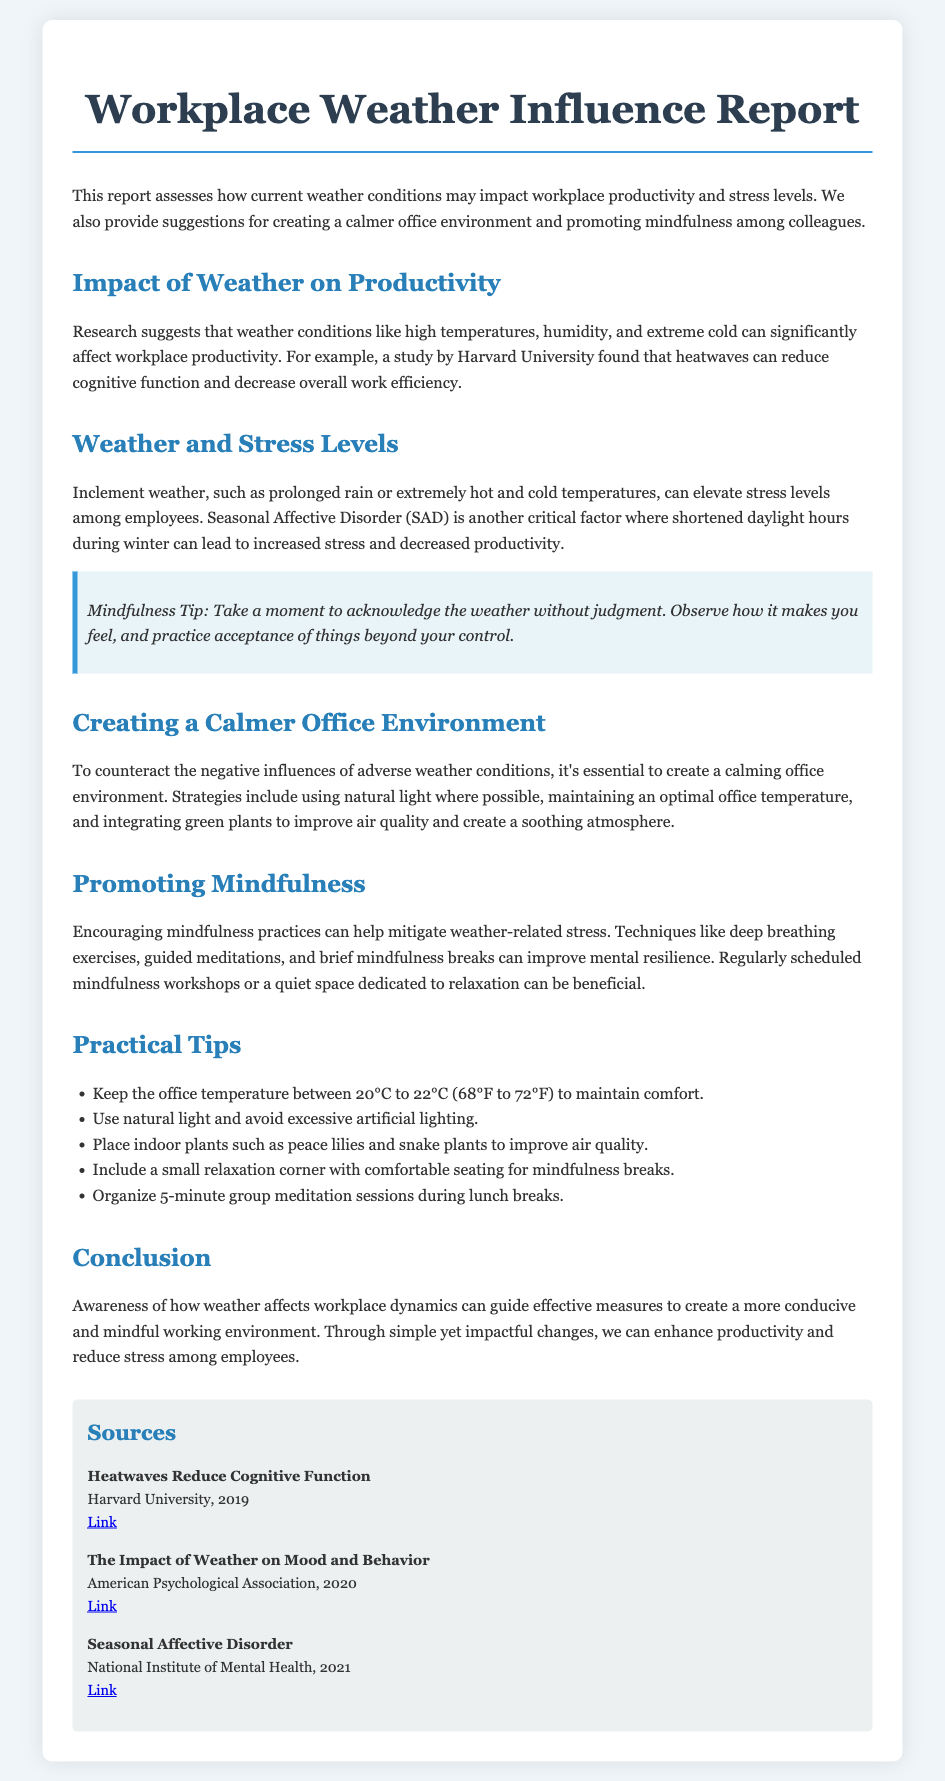What is the title of the report? The title of the report is the main heading at the top of the document.
Answer: Workplace Weather Influence Report What does the report assess? The report provides an overview of the content described in the introduction section.
Answer: Current weather conditions Which university conducted a study on heatwaves? The study referenced in the document highlights the research done by a specific university.
Answer: Harvard University What is the optimal office temperature range suggested? The temperature range is explicitly listed under practical tips for maintaining comfort.
Answer: 20°C to 22°C What technique is recommended for mitigating weather-related stress? The document lists several practices, focusing on a particular technique.
Answer: Deep breathing exercises What impact does prolonged rain have on stress levels? The report discusses how specific weather conditions affect employee well-being.
Answer: Elevate stress levels What can be placed in the office to improve air quality? The document suggests elements that enhance the office environment and air quality.
Answer: Indoor plants What is a suggested mindfulness practice during lunch breaks? The report mentions a brief activity that can be organized for colleagues.
Answer: 5-minute group meditation sessions What is the mood disorder associated with shortened daylight hours? The report identifies a specific condition linked to seasonal weather changes.
Answer: Seasonal Affective Disorder 